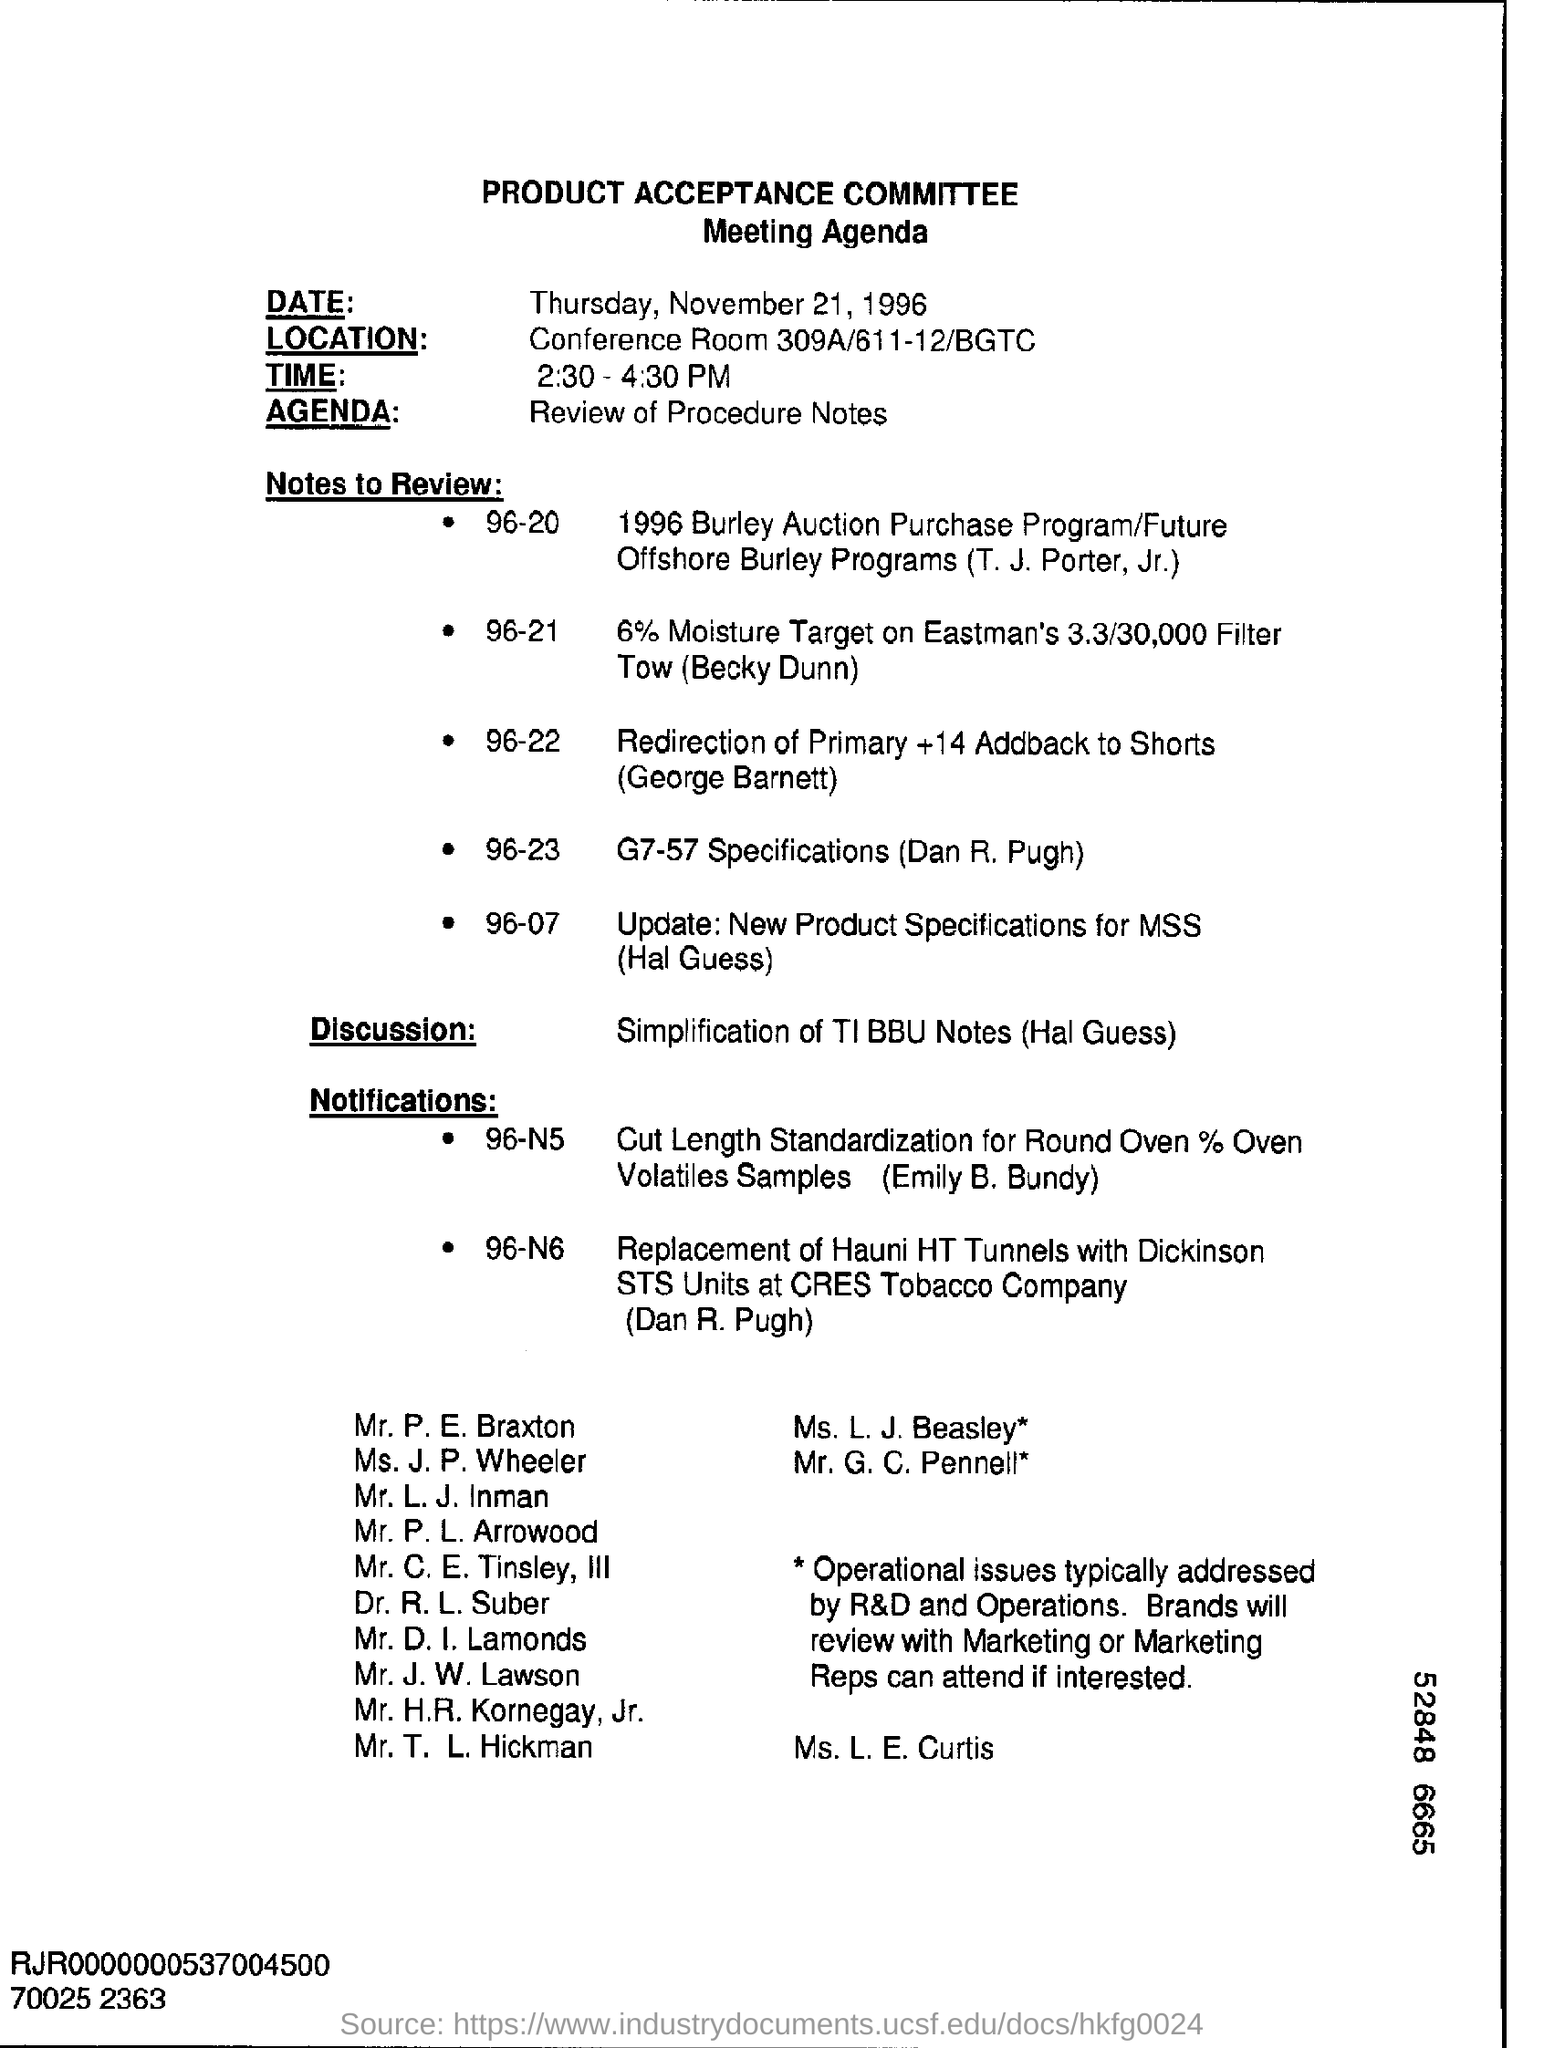Highlight a few significant elements in this photo. The date mentioned at the top of the document is Thursday, November 21, 1996. The agenda of this meeting is to review the procedure notes. The location of the conference is unknown. The conference room is located in 309A or 611-12, and it is part of the BGTC. 